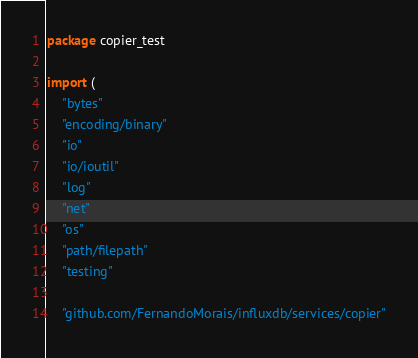Convert code to text. <code><loc_0><loc_0><loc_500><loc_500><_Go_>package copier_test

import (
	"bytes"
	"encoding/binary"
	"io"
	"io/ioutil"
	"log"
	"net"
	"os"
	"path/filepath"
	"testing"

	"github.com/FernandoMorais/influxdb/services/copier"</code> 